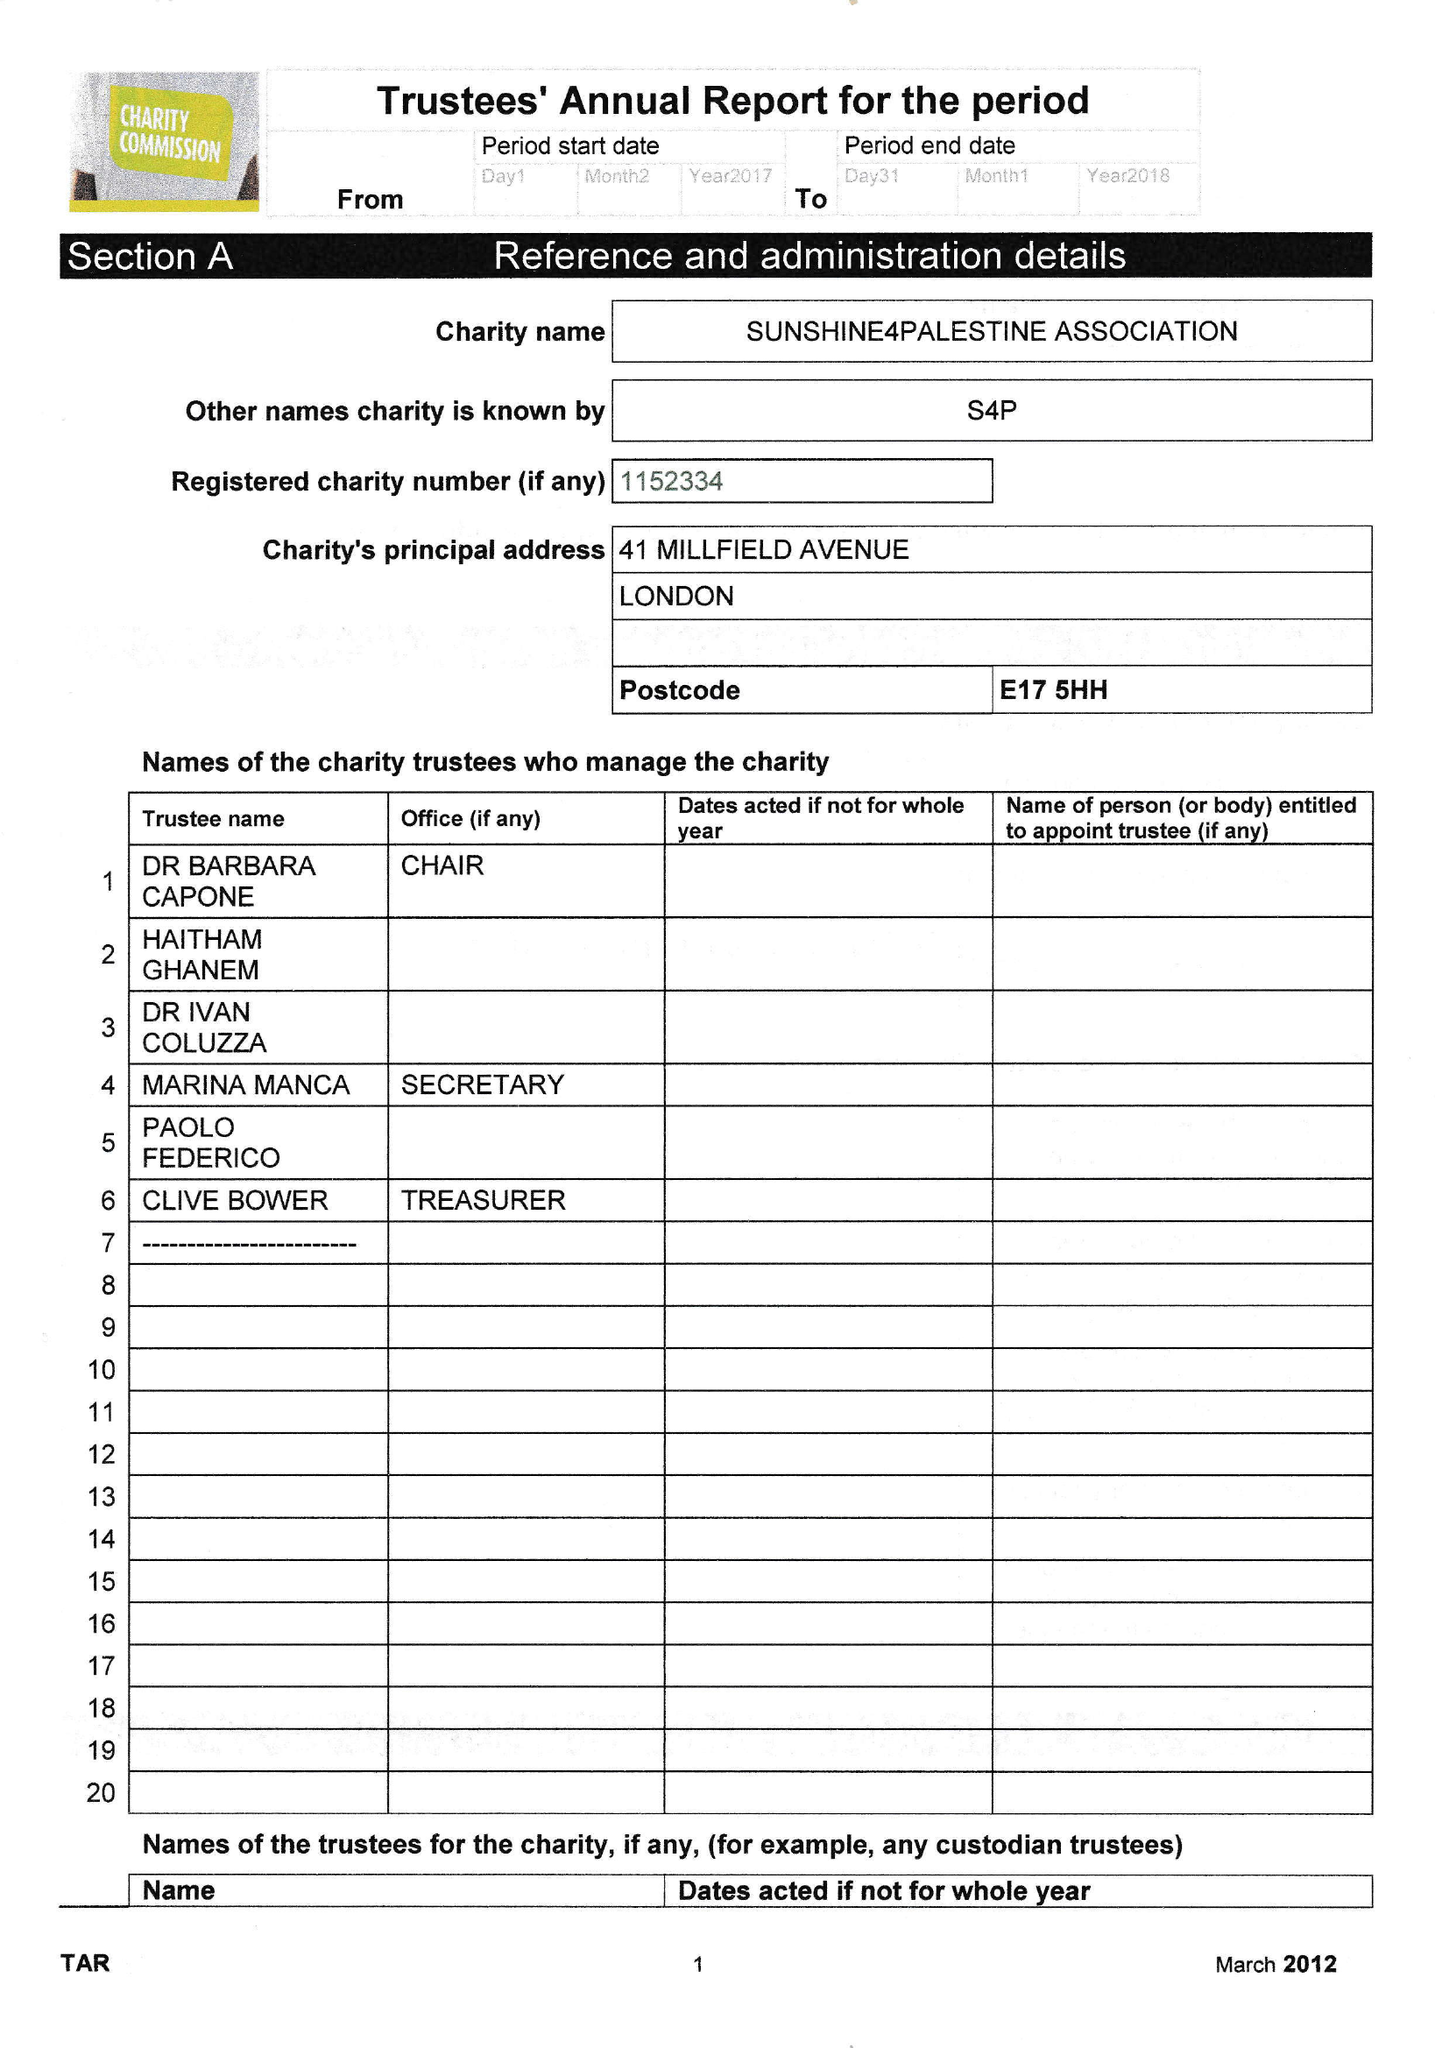What is the value for the address__postcode?
Answer the question using a single word or phrase. E17 5HH 